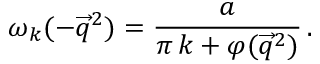<formula> <loc_0><loc_0><loc_500><loc_500>\omega _ { k } ( - \overrightarrow { q } ^ { 2 } ) = \frac { a } \pi \, k + \varphi ( \overrightarrow { q } ^ { 2 } ) } \, .</formula> 